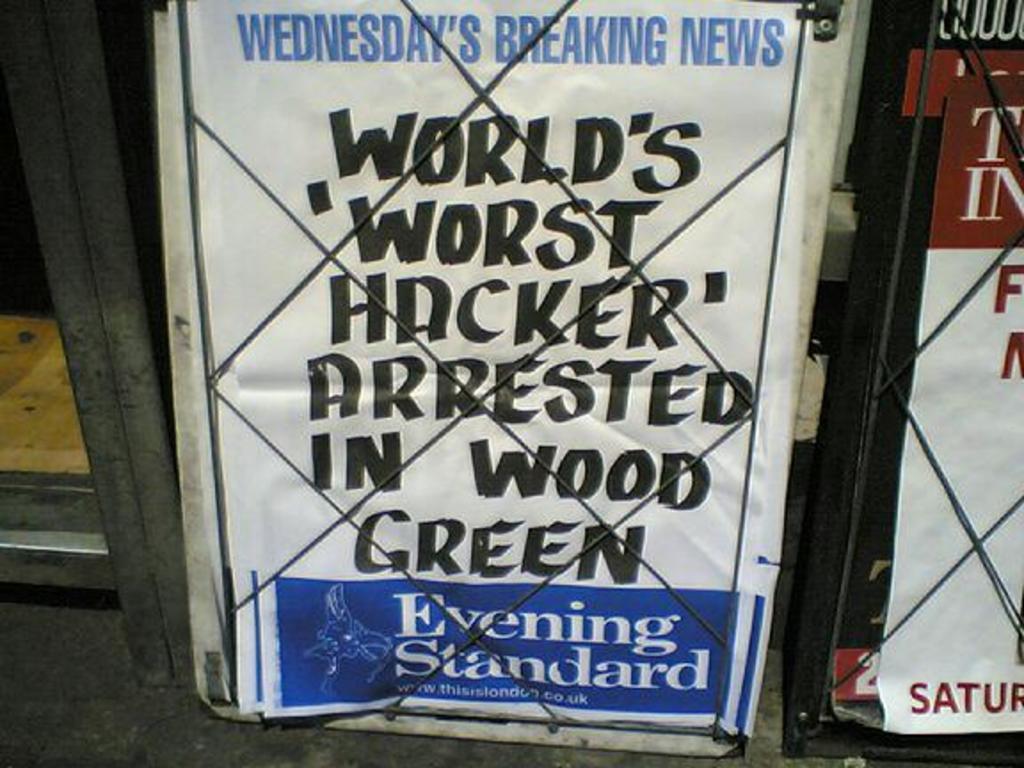What is the date on this game?
Provide a succinct answer. Unanswerable. Who was arrested?
Provide a succinct answer. World's worst hacker. 